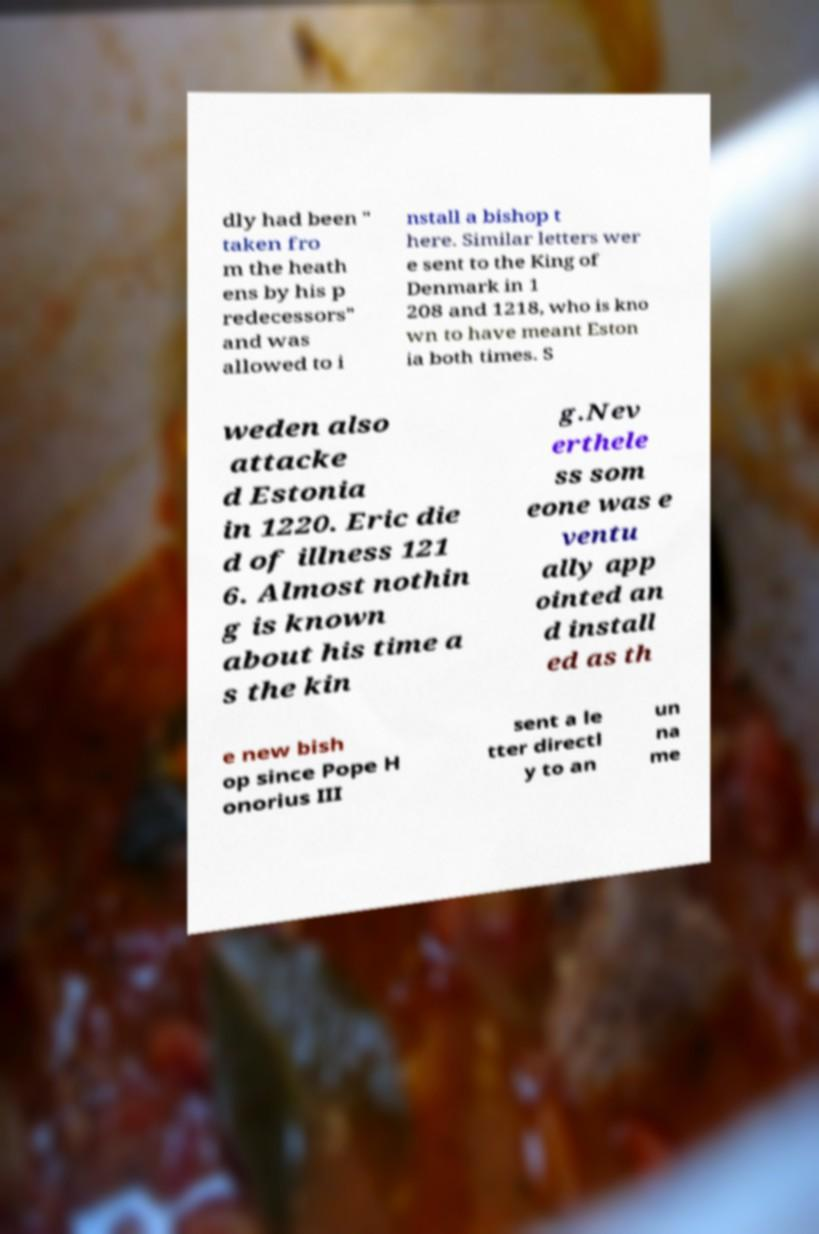For documentation purposes, I need the text within this image transcribed. Could you provide that? dly had been " taken fro m the heath ens by his p redecessors" and was allowed to i nstall a bishop t here. Similar letters wer e sent to the King of Denmark in 1 208 and 1218, who is kno wn to have meant Eston ia both times. S weden also attacke d Estonia in 1220. Eric die d of illness 121 6. Almost nothin g is known about his time a s the kin g.Nev erthele ss som eone was e ventu ally app ointed an d install ed as th e new bish op since Pope H onorius III sent a le tter directl y to an un na me 